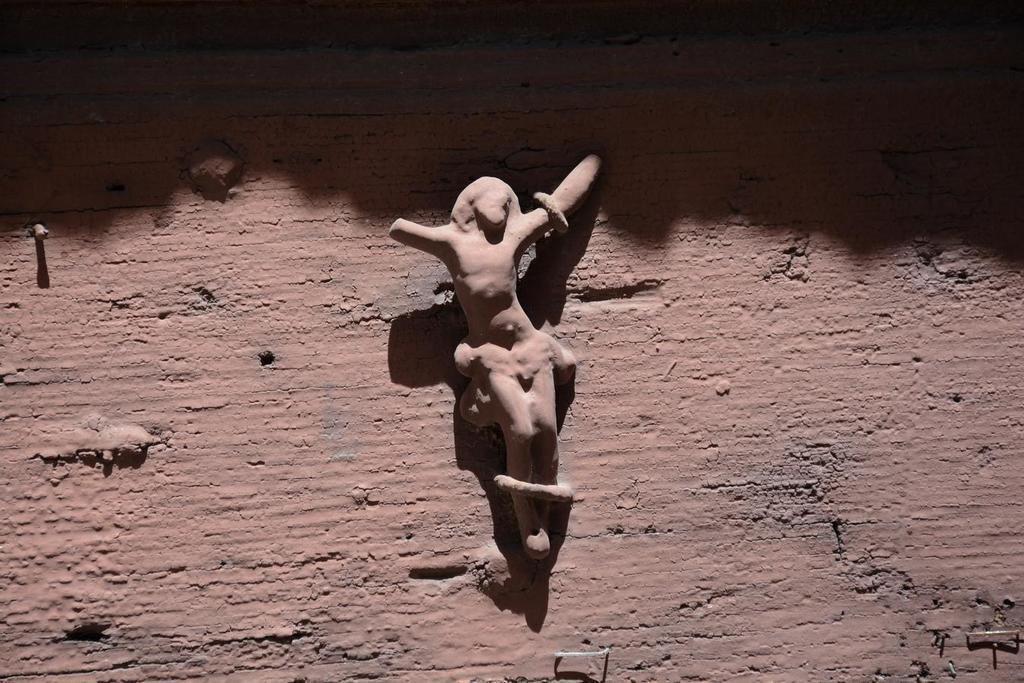What is depicted on the wall in the image? There is a sculpture of a person on the wall in the image. What type of basket is hanging from the key in the image? There is no basket or key present in the image; it only features a sculpture of a person on the wall. 